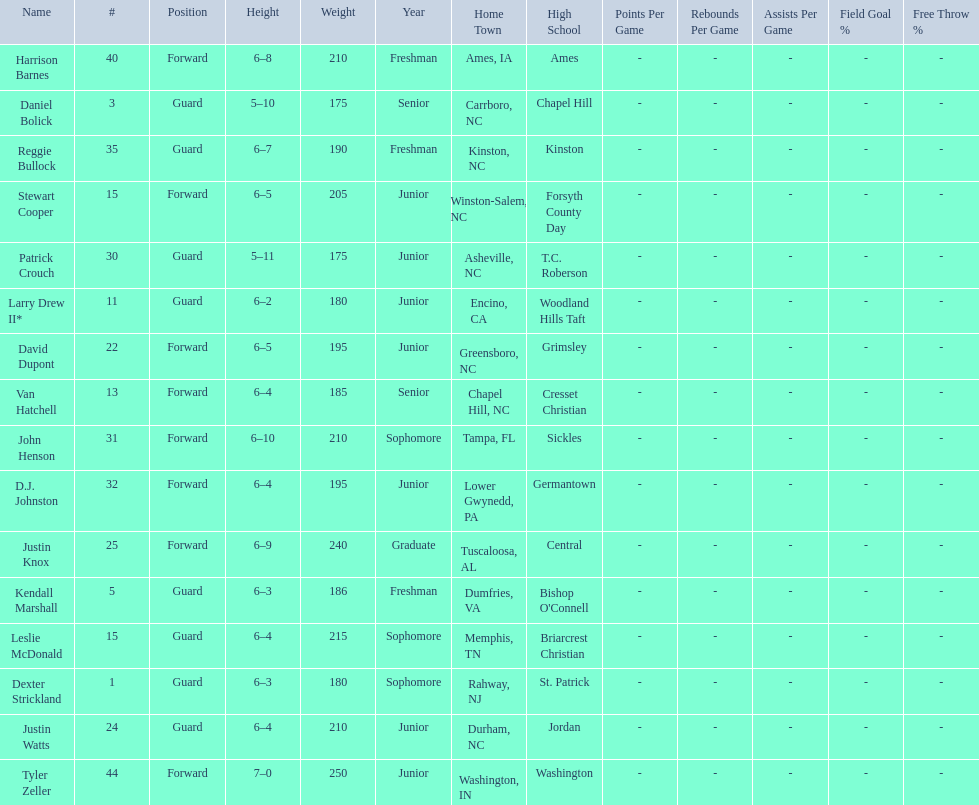Total number of players whose home town was in north carolina (nc) 7. 